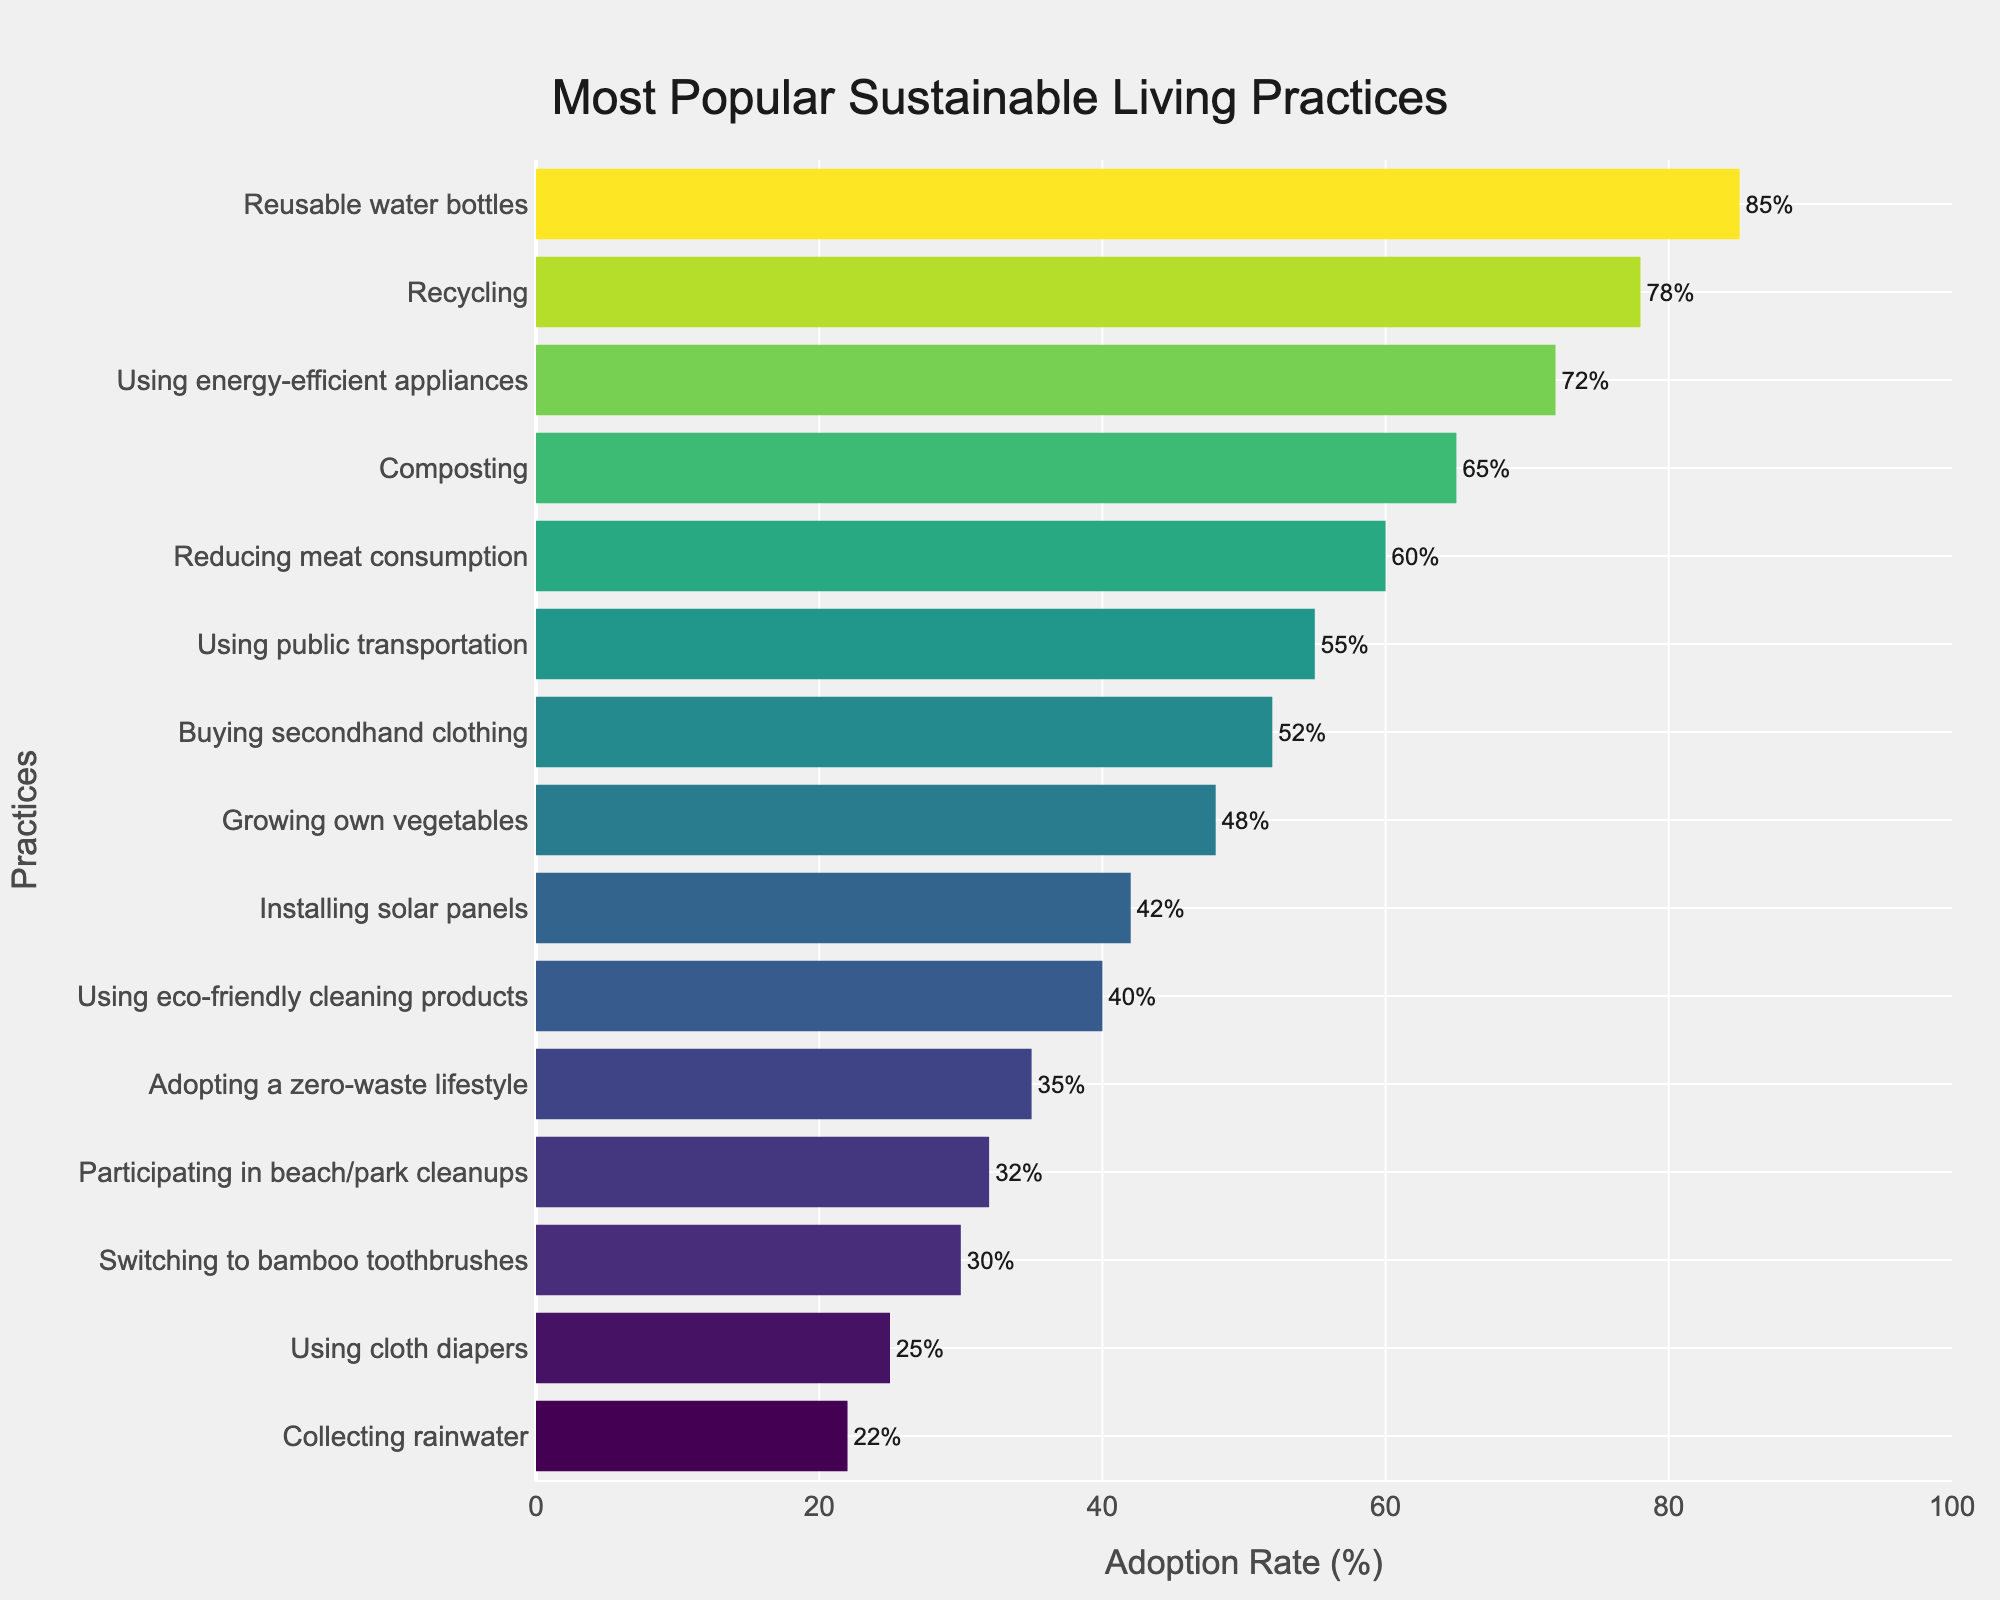What's the practice with the highest adoption rate? The bar chart shows the adoption rates of various sustainable living practices ranked from highest to lowest. To find the practice with the highest adoption rate, we look at the tallest bar.
Answer: Reusable water bottles Which practice has the lowest adoption rate? By examining the shortest bar in the bar chart, we can identify the practice with the lowest adoption rate.
Answer: Collecting rainwater How many practices have an adoption rate greater than 50%? To answer this, we count the number of bars that extend beyond the 50% mark on the x-axis.
Answer: 6 What is the average adoption rate of the top 5 most popular practices? First, identify the top 5 practices by adoption rate: Reusable water bottles, Recycling, Using energy-efficient appliances, Composting, and Reducing meat consumption. Their adoption rates are 85%, 78%, 72%, 65%, and 60% respectively. Sum these values (85 + 78 + 72 + 65 + 60 = 360) and divide by 5, resulting in 360/5 = 72%.
Answer: 72% Is the adoption rate of using public transportation greater or less than buying secondhand clothing? From the chart, the adoption rates are 55% for using public transportation and 52% for buying secondhand clothing. Comparing these two values, we see that 55% is greater.
Answer: Greater Which practices have adoption rates between 30% and 40%? By examining the bars that fall within the 30% to 40% range on the x-axis, we can identify the applicable practices.
Answer: Switching to bamboo toothbrushes, Using eco-friendly cleaning products What's the difference in adoption rates between composting and growing own vegetables? Look at the bars corresponding to composting (65%) and growing own vegetables (48%). Calculate the difference: 65% - 48% = 17%.
Answer: 17% How much higher is the adoption rate of recycling compared to participating in beach/park cleanups? Identify the adoption rates for recycling (78%) and participating in beach/park cleanups (32%), and then find the difference: 78% - 32% = 46%.
Answer: 46% What are the adoption rates of the three least popular practices? Identify the three practices with the lowest bars: Using cloth diapers (25%), Collecting rainwater (22%), and Participating in beach/park cleanups (32%).
Answer: 25%, 22%, 32% By how much does the adoption rate of using energy-efficient appliances exceed the adoption rate of using cloth diapers? Look at the bars for using energy-efficient appliances (72%) and using cloth diapers (25%). Calculate the difference: 72% - 25% = 47%.
Answer: 47% 